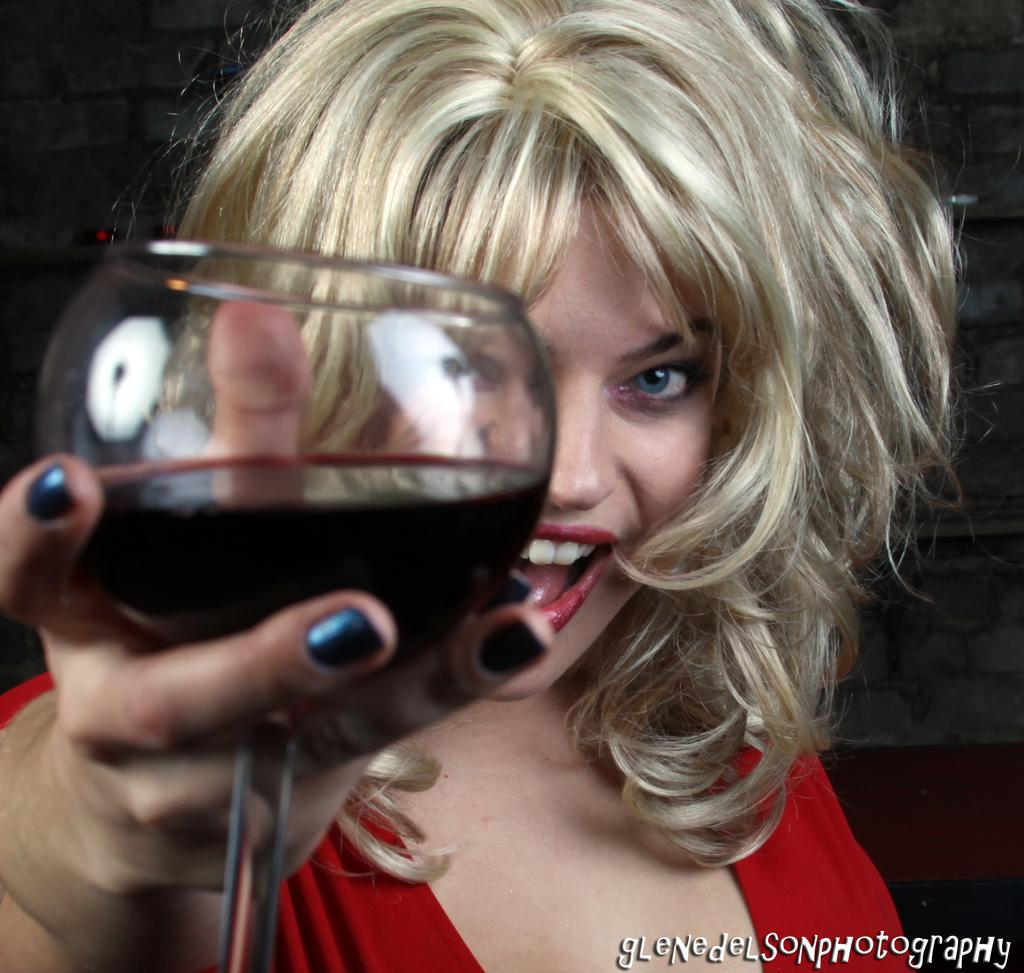Who is the main subject in the image? There is a girl in the image. What is the girl holding in the image? The girl is holding a glass. What is inside the glass that the girl is holding? The glass contains some liquid. What type of street can be seen in the image? There is no street present in the image; it features a girl holding a glass with liquid. Can you see a monkey in the image? There is no monkey present in the image. 